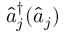Convert formula to latex. <formula><loc_0><loc_0><loc_500><loc_500>\hat { a } _ { j } ^ { \dagger } ( \hat { a } _ { j } )</formula> 